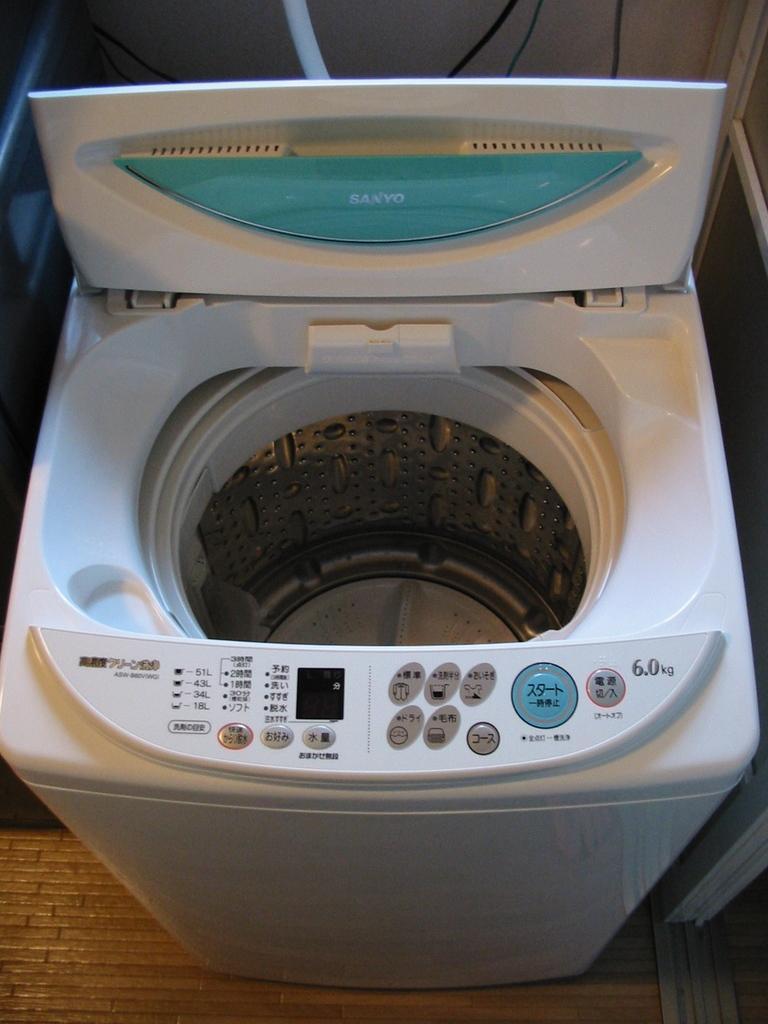Could you give a brief overview of what you see in this image? As we can see in the image there is a white color washing machine and here there are some buttons. 